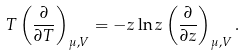Convert formula to latex. <formula><loc_0><loc_0><loc_500><loc_500>T \left ( \frac { \partial } { \partial T } \right ) _ { \mu , V } = - z \ln z \left ( \frac { \partial } { \partial z } \right ) _ { \mu , V } .</formula> 